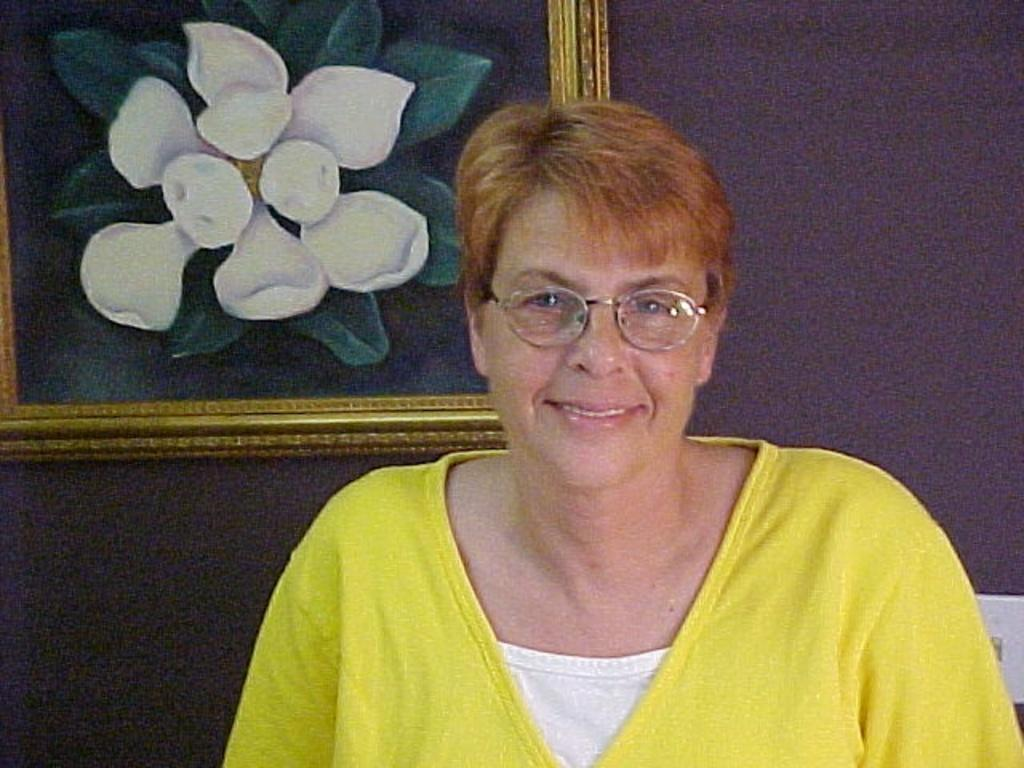Who is present in the image? There is a woman in the image. What is the woman wearing? The woman is wearing a yellow dress. What expression does the woman have? The woman is smiling. Can you describe any objects or features in the background of the image? There is a photo frame attached to the wall in the image. How much salt is present in the image? There is no salt visible in the image. What type of work is the woman doing in the image? The image does not show the woman performing any work or task. 